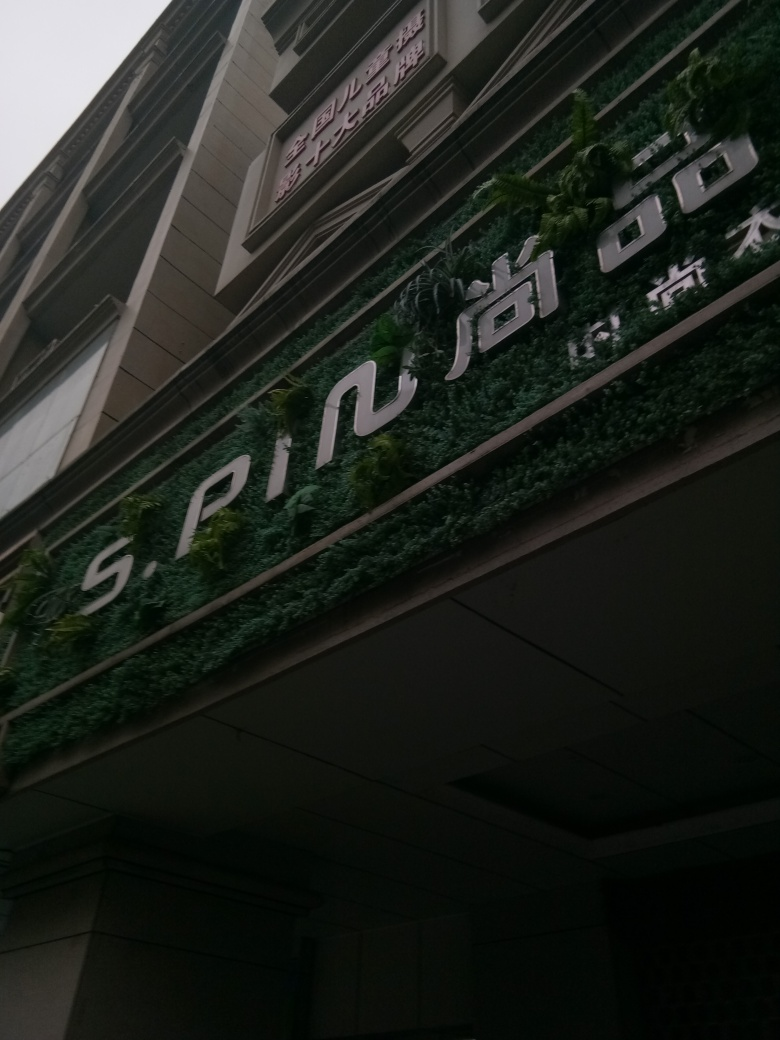What is the likely function of this building, given its external appearance? Although the image does not provide exhaustive details, the professional and polished appearance of the building's entrance, along with the modern signage, could indicate that this is a commercial or business-related edifice, such as a company headquarters, upscale retail space, or a boutique office building. 